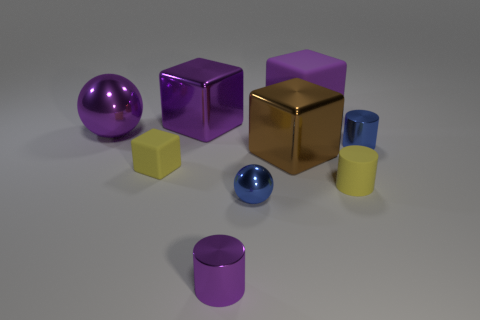What is the shape of the matte object that is the same size as the brown shiny block?
Ensure brevity in your answer.  Cube. How many balls have the same color as the big matte object?
Offer a terse response. 1. Are there fewer purple things that are in front of the yellow rubber cube than small blue metal cylinders to the right of the brown metallic block?
Offer a terse response. No. There is a yellow cylinder; are there any tiny yellow rubber blocks on the right side of it?
Make the answer very short. No. Is there a tiny cylinder to the left of the small shiny cylinder in front of the sphere that is in front of the blue metallic cylinder?
Your answer should be compact. No. There is a yellow matte object to the left of the purple rubber cube; is its shape the same as the brown metallic object?
Your answer should be compact. Yes. There is another sphere that is the same material as the large purple ball; what color is it?
Give a very brief answer. Blue. How many cylinders have the same material as the tiny purple thing?
Give a very brief answer. 1. The matte block left of the blue metallic object on the left side of the big purple block right of the tiny purple metal object is what color?
Offer a very short reply. Yellow. Do the purple rubber thing and the purple shiny ball have the same size?
Provide a succinct answer. Yes. 